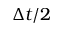<formula> <loc_0><loc_0><loc_500><loc_500>\Delta t / 2</formula> 